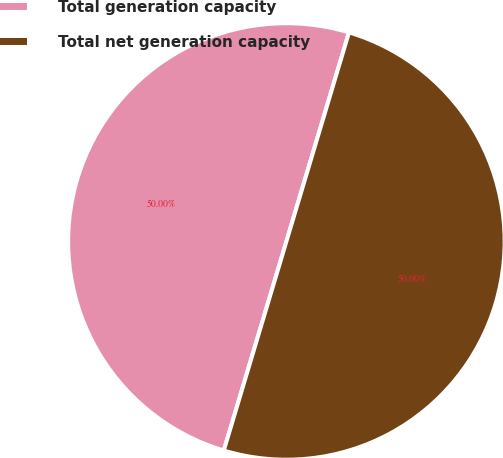Convert chart. <chart><loc_0><loc_0><loc_500><loc_500><pie_chart><fcel>Total generation capacity<fcel>Total net generation capacity<nl><fcel>50.0%<fcel>50.0%<nl></chart> 